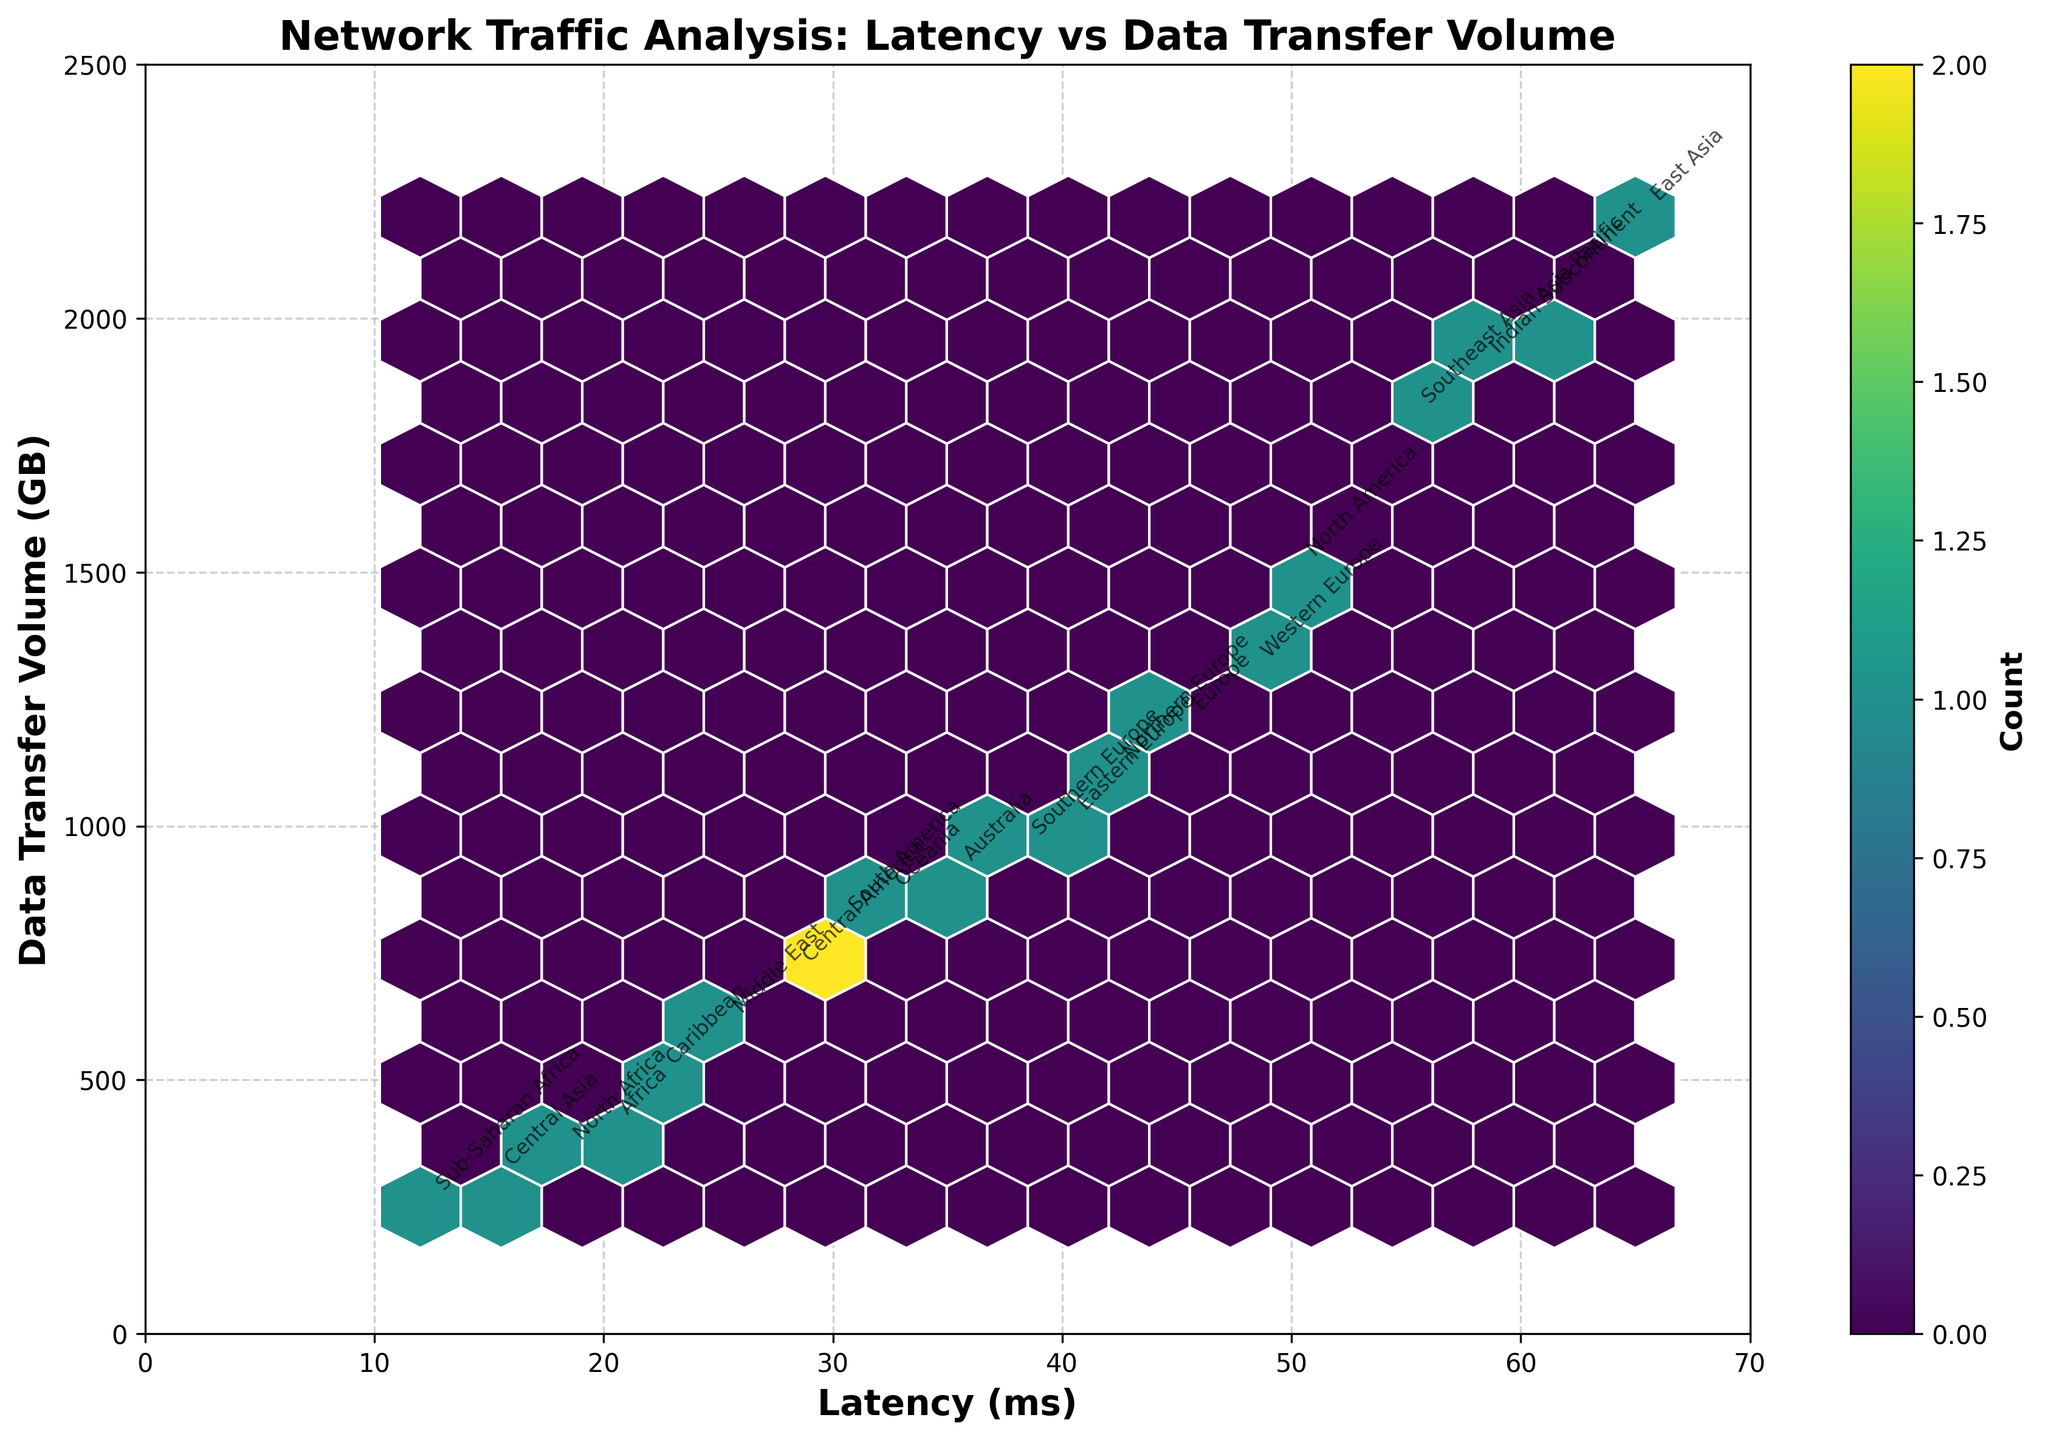what is the title of the figure? The title of the figure is displayed at the top and reads "Network Traffic Analysis: Latency vs Data Transfer Volume".
Answer: Network Traffic Analysis: Latency vs Data Transfer Volume what is the color map used in the hexbin plot? The color map used in the hexbin plot is described as 'viridis' with varying shades from light to dark greenish colors indicating different counts.
Answer: viridis how many data points are plotted in the figure? Each hexagon represents a binned area, but the number of individual regions from the provided data can be counted as annotations. There are 20 regions annotated on the plot.
Answer: 20 which region has the highest latency? By examining the plot, East Asia has the highest latency with a latency value of 65 ms.
Answer: East Asia Which region exhibits the largest data transfer volume? By looking at the topmost value in the plot, East Asia has the largest data transfer volume with a value of 2200 GB.
Answer: East Asia is there a trend between latency and data transfer volume seen in the plot? The plot shows that regions with higher latency generally also have higher data transfer volumes, indicating a positive correlation.
Answer: Yes what can be observed about the hexagons’ density in relation to latency? The density of the hexagons is higher in the regions of latency between 40 ms to 60 ms, indicating more data points in this range.
Answer: They are denser between 40 ms to 60 ms how does latency in North America compare with Europe? North America has a higher latency of 50 ms compared to Europe with 45 ms.
Answer: North America has higher latency What is the data transfer volume and latency for Sub-Saharan Africa? The annotation for Sub-Saharan Africa shows a latency of 12 ms and a data transfer volume of 250 GB.
Answer: Latency: 12 ms, Volume: 250 GB 